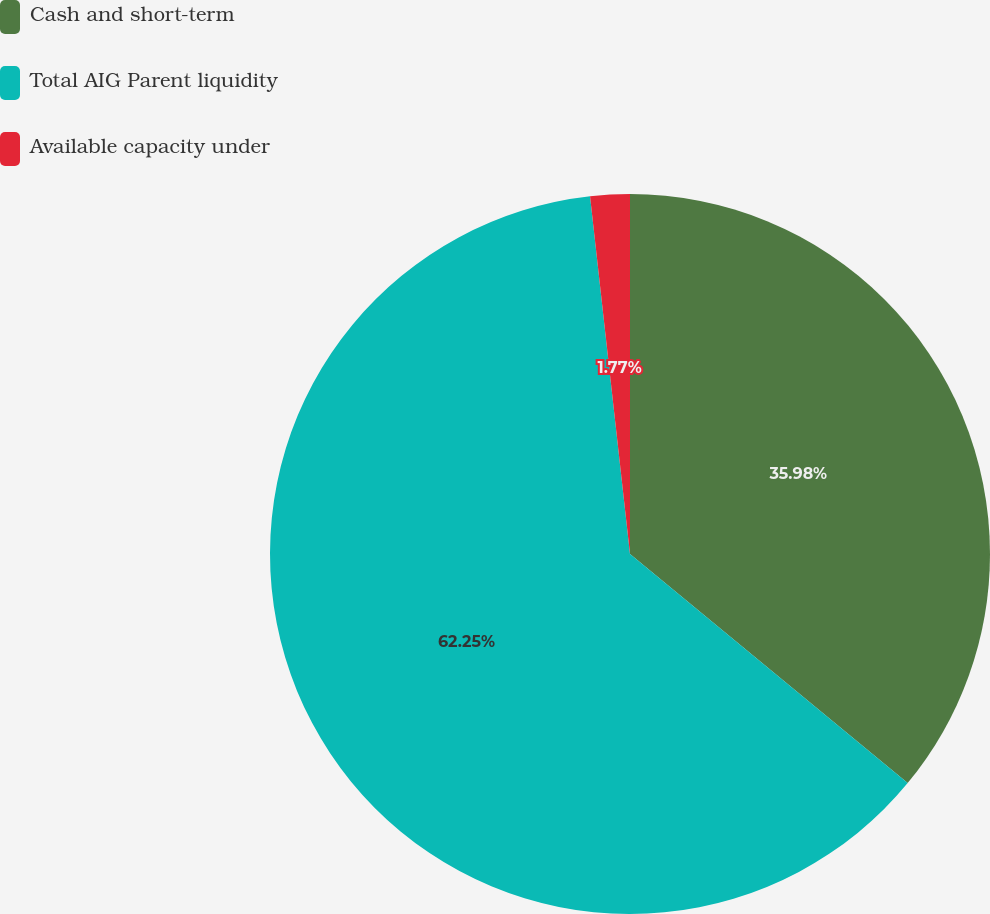<chart> <loc_0><loc_0><loc_500><loc_500><pie_chart><fcel>Cash and short-term<fcel>Total AIG Parent liquidity<fcel>Available capacity under<nl><fcel>35.98%<fcel>62.25%<fcel>1.77%<nl></chart> 